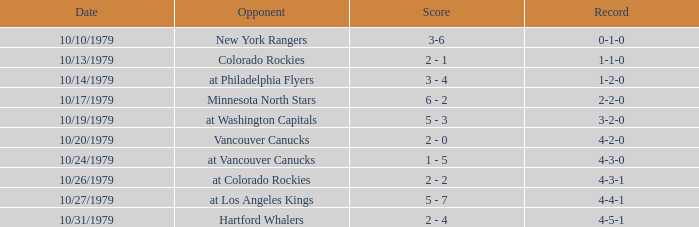What date is the record 4-3-0? 10/24/1979. 